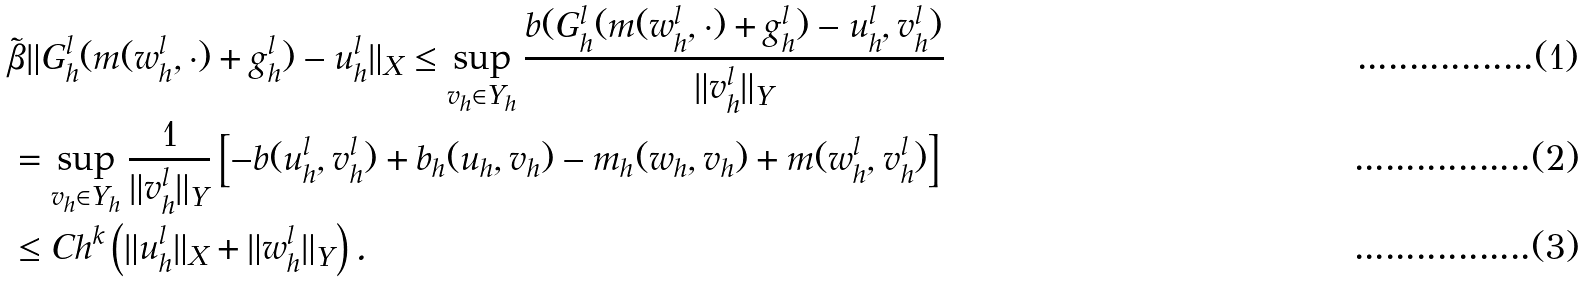<formula> <loc_0><loc_0><loc_500><loc_500>& \tilde { \beta } \| G _ { h } ^ { l } ( m ( w _ { h } ^ { l } , \cdot ) + g _ { h } ^ { l } ) - u _ { h } ^ { l } \| _ { X } \leq \sup _ { v _ { h } \in Y _ { h } } \frac { b ( G _ { h } ^ { l } ( m ( w _ { h } ^ { l } , \cdot ) + g _ { h } ^ { l } ) - u _ { h } ^ { l } , v _ { h } ^ { l } ) } { \| v _ { h } ^ { l } \| _ { Y } } \\ & = \sup _ { v _ { h } \in Y _ { h } } \frac { 1 } { \| v _ { h } ^ { l } \| _ { Y } } \left [ - b ( u _ { h } ^ { l } , v _ { h } ^ { l } ) + b _ { h } ( u _ { h } , v _ { h } ) - m _ { h } ( w _ { h } , v _ { h } ) + m ( w _ { h } ^ { l } , v _ { h } ^ { l } ) \right ] \\ & \leq C h ^ { k } \left ( \| u _ { h } ^ { l } \| _ { X } + \| w _ { h } ^ { l } \| _ { Y } \right ) .</formula> 